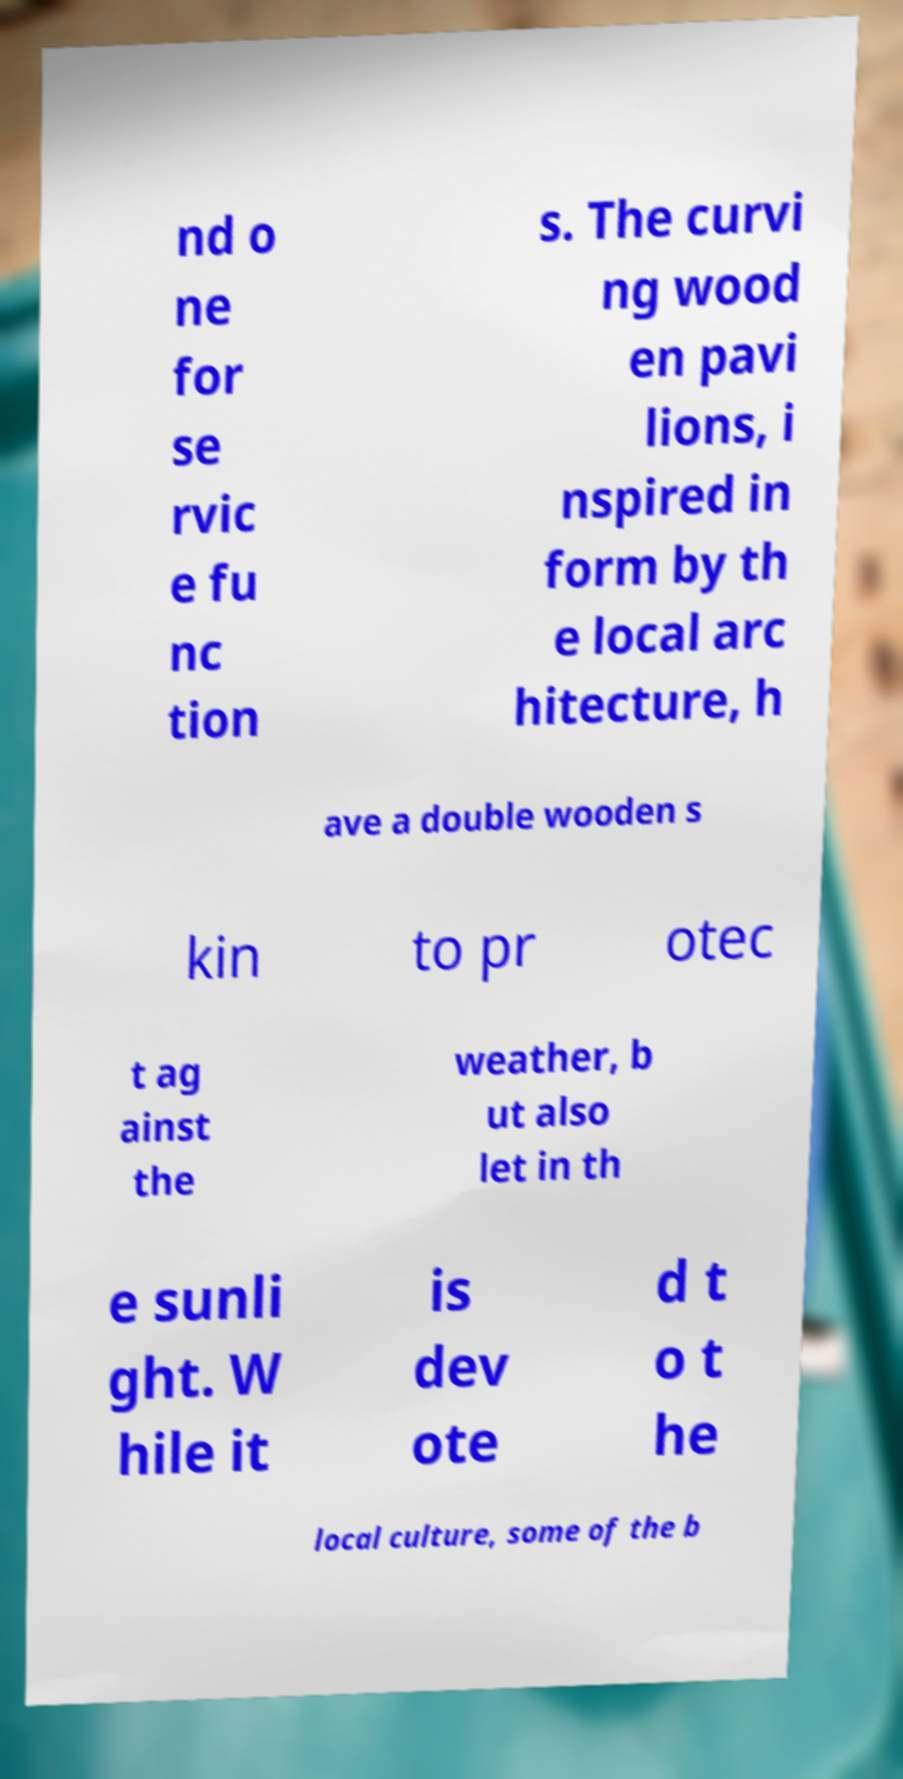There's text embedded in this image that I need extracted. Can you transcribe it verbatim? nd o ne for se rvic e fu nc tion s. The curvi ng wood en pavi lions, i nspired in form by th e local arc hitecture, h ave a double wooden s kin to pr otec t ag ainst the weather, b ut also let in th e sunli ght. W hile it is dev ote d t o t he local culture, some of the b 